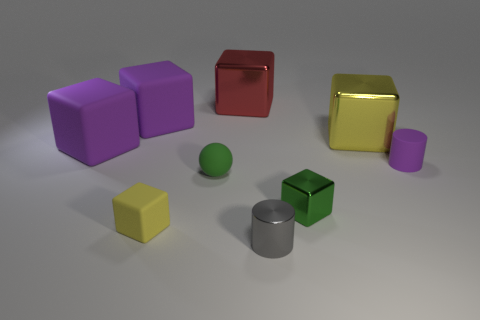Are there any small metal objects on the right side of the small gray metallic object?
Make the answer very short. Yes. Are there the same number of purple things behind the ball and tiny purple objects?
Offer a terse response. No. There is a green block that is to the right of the big matte thing behind the large yellow metallic object; is there a rubber cube right of it?
Give a very brief answer. No. What is the small purple thing made of?
Your answer should be very brief. Rubber. What number of other objects are the same shape as the yellow matte thing?
Provide a succinct answer. 5. Is the large yellow thing the same shape as the small yellow object?
Your answer should be very brief. Yes. What number of objects are big blocks to the left of the tiny yellow rubber thing or small cylinders in front of the small yellow matte block?
Provide a short and direct response. 3. How many things are either green rubber balls or green shiny things?
Your answer should be very brief. 2. There is a tiny green object that is left of the small gray shiny cylinder; how many cubes are to the right of it?
Provide a succinct answer. 3. What number of other objects are the same size as the red cube?
Make the answer very short. 3. 